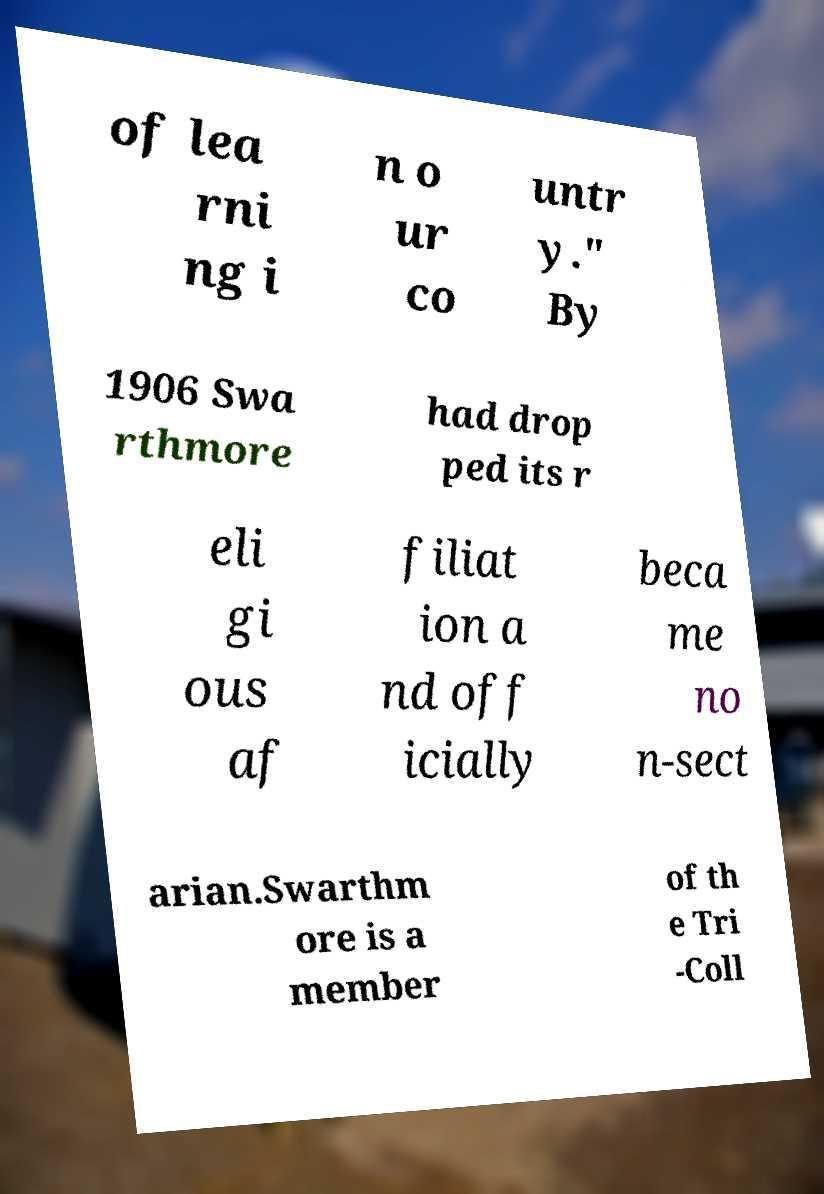I need the written content from this picture converted into text. Can you do that? of lea rni ng i n o ur co untr y." By 1906 Swa rthmore had drop ped its r eli gi ous af filiat ion a nd off icially beca me no n-sect arian.Swarthm ore is a member of th e Tri -Coll 